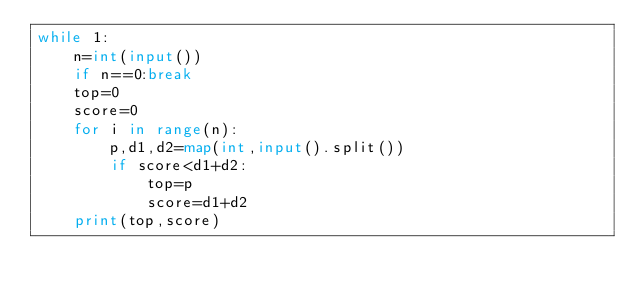Convert code to text. <code><loc_0><loc_0><loc_500><loc_500><_Python_>while 1:
    n=int(input())
    if n==0:break
    top=0
    score=0
    for i in range(n):
        p,d1,d2=map(int,input().split())
        if score<d1+d2:
            top=p
            score=d1+d2
    print(top,score)
</code> 